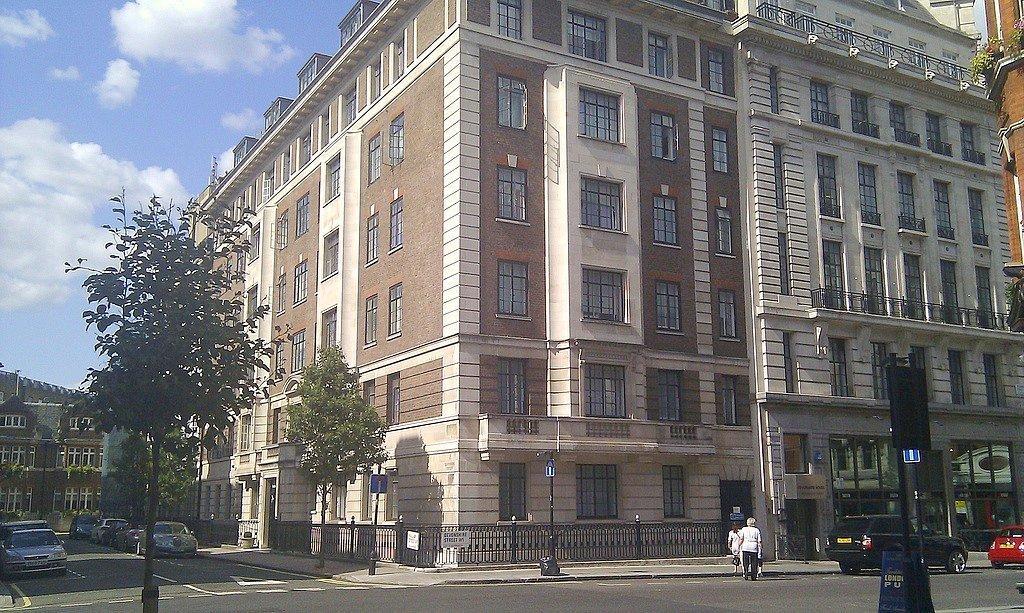Describe this image in one or two sentences. In this image we can see sky with clouds, trees, buildings, street poles, street lights, bins, motor vehicles on the road, person's, plants and sign boards. 